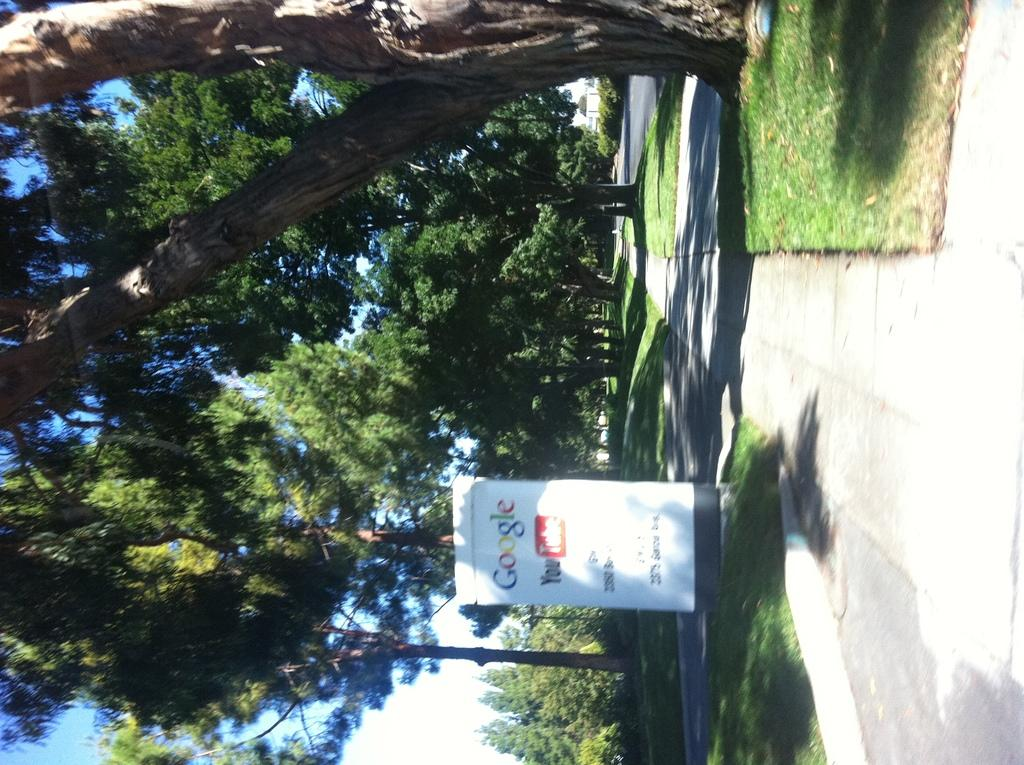What type of vegetation is present on the ground in the front of the image? There is grass on the ground in the front of the image. What can be seen in the center of the image? There is a board with text in the center of the image. What is visible in the background of the image? There are trees in the background of the image. Can you tell me how many birds are perched on the board in the image? There are no birds present in the image; it only features grass, a board with text, and trees in the background. What type of heart-related information is displayed on the board in the image? There is no heart-related information displayed on the board in the image; it only contains text that can be seen. 